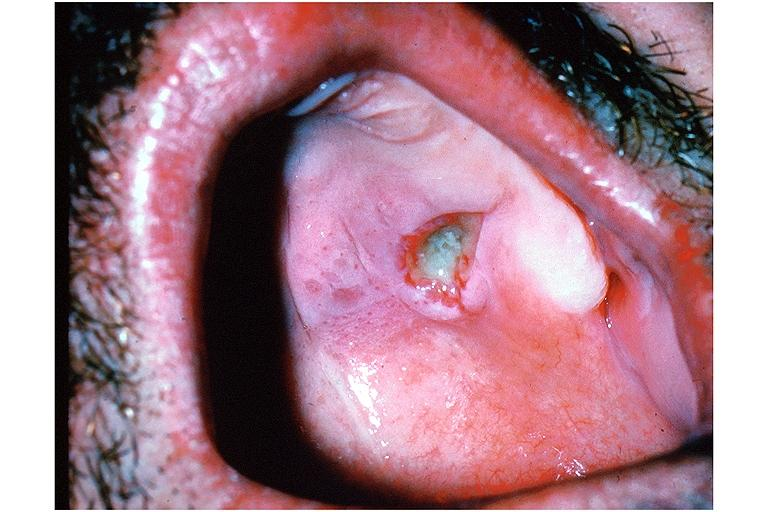what does this image show?
Answer the question using a single word or phrase. Necrotizing sialometaplasia 